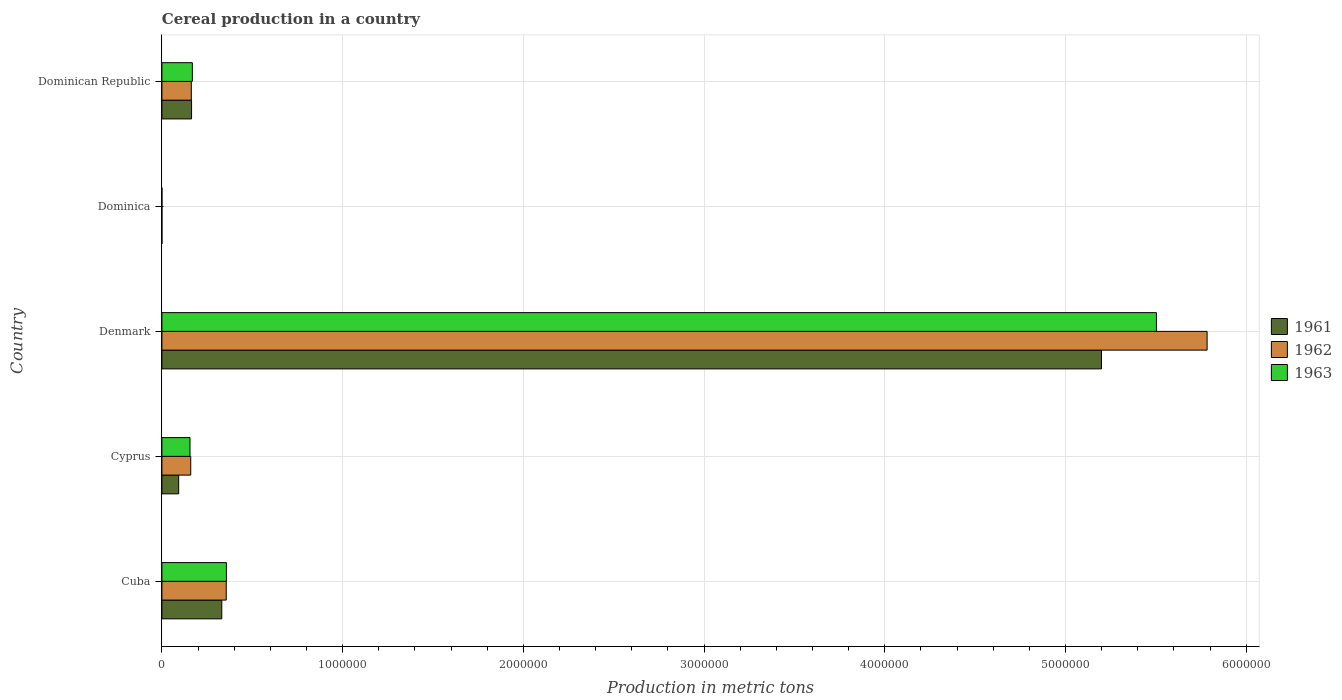How many bars are there on the 5th tick from the top?
Provide a succinct answer. 3. How many bars are there on the 4th tick from the bottom?
Ensure brevity in your answer.  3. What is the label of the 4th group of bars from the top?
Ensure brevity in your answer.  Cyprus. What is the total cereal production in 1961 in Dominican Republic?
Provide a short and direct response. 1.64e+05. Across all countries, what is the maximum total cereal production in 1963?
Provide a succinct answer. 5.50e+06. Across all countries, what is the minimum total cereal production in 1962?
Your answer should be compact. 130. In which country was the total cereal production in 1961 maximum?
Offer a terse response. Denmark. In which country was the total cereal production in 1961 minimum?
Your response must be concise. Dominica. What is the total total cereal production in 1962 in the graph?
Offer a very short reply. 6.46e+06. What is the difference between the total cereal production in 1963 in Cuba and that in Dominica?
Provide a succinct answer. 3.57e+05. What is the difference between the total cereal production in 1963 in Dominica and the total cereal production in 1962 in Cyprus?
Offer a terse response. -1.59e+05. What is the average total cereal production in 1963 per country?
Provide a short and direct response. 1.24e+06. What is the difference between the total cereal production in 1963 and total cereal production in 1962 in Denmark?
Ensure brevity in your answer.  -2.80e+05. What is the ratio of the total cereal production in 1962 in Cyprus to that in Dominica?
Provide a succinct answer. 1227.02. Is the total cereal production in 1961 in Cyprus less than that in Denmark?
Ensure brevity in your answer.  Yes. What is the difference between the highest and the second highest total cereal production in 1963?
Your answer should be very brief. 5.15e+06. What is the difference between the highest and the lowest total cereal production in 1962?
Make the answer very short. 5.78e+06. What does the 3rd bar from the top in Dominican Republic represents?
Your answer should be very brief. 1961. How many bars are there?
Make the answer very short. 15. Are all the bars in the graph horizontal?
Offer a terse response. Yes. What is the difference between two consecutive major ticks on the X-axis?
Your answer should be very brief. 1.00e+06. Where does the legend appear in the graph?
Provide a succinct answer. Center right. How many legend labels are there?
Provide a succinct answer. 3. How are the legend labels stacked?
Keep it short and to the point. Vertical. What is the title of the graph?
Keep it short and to the point. Cereal production in a country. What is the label or title of the X-axis?
Offer a very short reply. Production in metric tons. What is the Production in metric tons in 1961 in Cuba?
Your response must be concise. 3.31e+05. What is the Production in metric tons of 1962 in Cuba?
Offer a terse response. 3.56e+05. What is the Production in metric tons in 1963 in Cuba?
Keep it short and to the point. 3.57e+05. What is the Production in metric tons in 1961 in Cyprus?
Your answer should be compact. 9.28e+04. What is the Production in metric tons in 1962 in Cyprus?
Offer a terse response. 1.60e+05. What is the Production in metric tons in 1963 in Cyprus?
Give a very brief answer. 1.56e+05. What is the Production in metric tons of 1961 in Denmark?
Provide a succinct answer. 5.20e+06. What is the Production in metric tons in 1962 in Denmark?
Give a very brief answer. 5.78e+06. What is the Production in metric tons in 1963 in Denmark?
Keep it short and to the point. 5.50e+06. What is the Production in metric tons in 1961 in Dominica?
Make the answer very short. 130. What is the Production in metric tons in 1962 in Dominica?
Ensure brevity in your answer.  130. What is the Production in metric tons in 1963 in Dominica?
Give a very brief answer. 140. What is the Production in metric tons in 1961 in Dominican Republic?
Your answer should be very brief. 1.64e+05. What is the Production in metric tons of 1962 in Dominican Republic?
Provide a succinct answer. 1.63e+05. What is the Production in metric tons in 1963 in Dominican Republic?
Provide a succinct answer. 1.68e+05. Across all countries, what is the maximum Production in metric tons in 1961?
Give a very brief answer. 5.20e+06. Across all countries, what is the maximum Production in metric tons of 1962?
Your answer should be very brief. 5.78e+06. Across all countries, what is the maximum Production in metric tons of 1963?
Offer a very short reply. 5.50e+06. Across all countries, what is the minimum Production in metric tons in 1961?
Provide a short and direct response. 130. Across all countries, what is the minimum Production in metric tons in 1962?
Your answer should be very brief. 130. Across all countries, what is the minimum Production in metric tons in 1963?
Your response must be concise. 140. What is the total Production in metric tons of 1961 in the graph?
Provide a short and direct response. 5.79e+06. What is the total Production in metric tons of 1962 in the graph?
Your answer should be very brief. 6.46e+06. What is the total Production in metric tons in 1963 in the graph?
Ensure brevity in your answer.  6.18e+06. What is the difference between the Production in metric tons of 1961 in Cuba and that in Cyprus?
Your response must be concise. 2.39e+05. What is the difference between the Production in metric tons of 1962 in Cuba and that in Cyprus?
Your response must be concise. 1.97e+05. What is the difference between the Production in metric tons in 1963 in Cuba and that in Cyprus?
Provide a succinct answer. 2.01e+05. What is the difference between the Production in metric tons of 1961 in Cuba and that in Denmark?
Provide a succinct answer. -4.87e+06. What is the difference between the Production in metric tons in 1962 in Cuba and that in Denmark?
Ensure brevity in your answer.  -5.43e+06. What is the difference between the Production in metric tons in 1963 in Cuba and that in Denmark?
Your answer should be very brief. -5.15e+06. What is the difference between the Production in metric tons in 1961 in Cuba and that in Dominica?
Keep it short and to the point. 3.31e+05. What is the difference between the Production in metric tons of 1962 in Cuba and that in Dominica?
Offer a very short reply. 3.56e+05. What is the difference between the Production in metric tons in 1963 in Cuba and that in Dominica?
Offer a very short reply. 3.57e+05. What is the difference between the Production in metric tons in 1961 in Cuba and that in Dominican Republic?
Offer a very short reply. 1.67e+05. What is the difference between the Production in metric tons in 1962 in Cuba and that in Dominican Republic?
Your response must be concise. 1.93e+05. What is the difference between the Production in metric tons of 1963 in Cuba and that in Dominican Republic?
Make the answer very short. 1.88e+05. What is the difference between the Production in metric tons of 1961 in Cyprus and that in Denmark?
Give a very brief answer. -5.11e+06. What is the difference between the Production in metric tons in 1962 in Cyprus and that in Denmark?
Keep it short and to the point. -5.62e+06. What is the difference between the Production in metric tons in 1963 in Cyprus and that in Denmark?
Your response must be concise. -5.35e+06. What is the difference between the Production in metric tons of 1961 in Cyprus and that in Dominica?
Your answer should be very brief. 9.26e+04. What is the difference between the Production in metric tons of 1962 in Cyprus and that in Dominica?
Provide a succinct answer. 1.59e+05. What is the difference between the Production in metric tons of 1963 in Cyprus and that in Dominica?
Make the answer very short. 1.55e+05. What is the difference between the Production in metric tons of 1961 in Cyprus and that in Dominican Republic?
Provide a short and direct response. -7.13e+04. What is the difference between the Production in metric tons of 1962 in Cyprus and that in Dominican Republic?
Your answer should be very brief. -3252. What is the difference between the Production in metric tons in 1963 in Cyprus and that in Dominican Republic?
Your answer should be very brief. -1.29e+04. What is the difference between the Production in metric tons in 1961 in Denmark and that in Dominica?
Offer a terse response. 5.20e+06. What is the difference between the Production in metric tons in 1962 in Denmark and that in Dominica?
Offer a terse response. 5.78e+06. What is the difference between the Production in metric tons of 1963 in Denmark and that in Dominica?
Offer a terse response. 5.50e+06. What is the difference between the Production in metric tons of 1961 in Denmark and that in Dominican Republic?
Offer a terse response. 5.03e+06. What is the difference between the Production in metric tons in 1962 in Denmark and that in Dominican Republic?
Ensure brevity in your answer.  5.62e+06. What is the difference between the Production in metric tons in 1963 in Denmark and that in Dominican Republic?
Your answer should be very brief. 5.33e+06. What is the difference between the Production in metric tons in 1961 in Dominica and that in Dominican Republic?
Provide a succinct answer. -1.64e+05. What is the difference between the Production in metric tons in 1962 in Dominica and that in Dominican Republic?
Offer a terse response. -1.63e+05. What is the difference between the Production in metric tons in 1963 in Dominica and that in Dominican Republic?
Make the answer very short. -1.68e+05. What is the difference between the Production in metric tons of 1961 in Cuba and the Production in metric tons of 1962 in Cyprus?
Offer a very short reply. 1.72e+05. What is the difference between the Production in metric tons in 1961 in Cuba and the Production in metric tons in 1963 in Cyprus?
Offer a terse response. 1.76e+05. What is the difference between the Production in metric tons of 1962 in Cuba and the Production in metric tons of 1963 in Cyprus?
Keep it short and to the point. 2.00e+05. What is the difference between the Production in metric tons in 1961 in Cuba and the Production in metric tons in 1962 in Denmark?
Ensure brevity in your answer.  -5.45e+06. What is the difference between the Production in metric tons in 1961 in Cuba and the Production in metric tons in 1963 in Denmark?
Ensure brevity in your answer.  -5.17e+06. What is the difference between the Production in metric tons in 1962 in Cuba and the Production in metric tons in 1963 in Denmark?
Make the answer very short. -5.15e+06. What is the difference between the Production in metric tons in 1961 in Cuba and the Production in metric tons in 1962 in Dominica?
Offer a very short reply. 3.31e+05. What is the difference between the Production in metric tons of 1961 in Cuba and the Production in metric tons of 1963 in Dominica?
Give a very brief answer. 3.31e+05. What is the difference between the Production in metric tons in 1962 in Cuba and the Production in metric tons in 1963 in Dominica?
Give a very brief answer. 3.56e+05. What is the difference between the Production in metric tons of 1961 in Cuba and the Production in metric tons of 1962 in Dominican Republic?
Your answer should be very brief. 1.69e+05. What is the difference between the Production in metric tons in 1961 in Cuba and the Production in metric tons in 1963 in Dominican Republic?
Provide a short and direct response. 1.63e+05. What is the difference between the Production in metric tons in 1962 in Cuba and the Production in metric tons in 1963 in Dominican Republic?
Your response must be concise. 1.88e+05. What is the difference between the Production in metric tons in 1961 in Cyprus and the Production in metric tons in 1962 in Denmark?
Ensure brevity in your answer.  -5.69e+06. What is the difference between the Production in metric tons in 1961 in Cyprus and the Production in metric tons in 1963 in Denmark?
Provide a succinct answer. -5.41e+06. What is the difference between the Production in metric tons in 1962 in Cyprus and the Production in metric tons in 1963 in Denmark?
Provide a succinct answer. -5.34e+06. What is the difference between the Production in metric tons of 1961 in Cyprus and the Production in metric tons of 1962 in Dominica?
Your answer should be very brief. 9.26e+04. What is the difference between the Production in metric tons of 1961 in Cyprus and the Production in metric tons of 1963 in Dominica?
Make the answer very short. 9.26e+04. What is the difference between the Production in metric tons in 1962 in Cyprus and the Production in metric tons in 1963 in Dominica?
Ensure brevity in your answer.  1.59e+05. What is the difference between the Production in metric tons of 1961 in Cyprus and the Production in metric tons of 1962 in Dominican Republic?
Make the answer very short. -7.00e+04. What is the difference between the Production in metric tons of 1961 in Cyprus and the Production in metric tons of 1963 in Dominican Republic?
Provide a succinct answer. -7.57e+04. What is the difference between the Production in metric tons of 1962 in Cyprus and the Production in metric tons of 1963 in Dominican Republic?
Your answer should be very brief. -8920. What is the difference between the Production in metric tons in 1961 in Denmark and the Production in metric tons in 1962 in Dominica?
Your answer should be compact. 5.20e+06. What is the difference between the Production in metric tons of 1961 in Denmark and the Production in metric tons of 1963 in Dominica?
Ensure brevity in your answer.  5.20e+06. What is the difference between the Production in metric tons of 1962 in Denmark and the Production in metric tons of 1963 in Dominica?
Provide a short and direct response. 5.78e+06. What is the difference between the Production in metric tons of 1961 in Denmark and the Production in metric tons of 1962 in Dominican Republic?
Provide a succinct answer. 5.04e+06. What is the difference between the Production in metric tons in 1961 in Denmark and the Production in metric tons in 1963 in Dominican Republic?
Your answer should be very brief. 5.03e+06. What is the difference between the Production in metric tons in 1962 in Denmark and the Production in metric tons in 1963 in Dominican Republic?
Your answer should be very brief. 5.61e+06. What is the difference between the Production in metric tons in 1961 in Dominica and the Production in metric tons in 1962 in Dominican Republic?
Ensure brevity in your answer.  -1.63e+05. What is the difference between the Production in metric tons of 1961 in Dominica and the Production in metric tons of 1963 in Dominican Republic?
Give a very brief answer. -1.68e+05. What is the difference between the Production in metric tons of 1962 in Dominica and the Production in metric tons of 1963 in Dominican Republic?
Your answer should be very brief. -1.68e+05. What is the average Production in metric tons in 1961 per country?
Your response must be concise. 1.16e+06. What is the average Production in metric tons of 1962 per country?
Give a very brief answer. 1.29e+06. What is the average Production in metric tons of 1963 per country?
Your answer should be very brief. 1.24e+06. What is the difference between the Production in metric tons of 1961 and Production in metric tons of 1962 in Cuba?
Keep it short and to the point. -2.47e+04. What is the difference between the Production in metric tons in 1961 and Production in metric tons in 1963 in Cuba?
Provide a short and direct response. -2.56e+04. What is the difference between the Production in metric tons of 1962 and Production in metric tons of 1963 in Cuba?
Keep it short and to the point. -880. What is the difference between the Production in metric tons in 1961 and Production in metric tons in 1962 in Cyprus?
Provide a succinct answer. -6.68e+04. What is the difference between the Production in metric tons of 1961 and Production in metric tons of 1963 in Cyprus?
Offer a terse response. -6.28e+04. What is the difference between the Production in metric tons of 1962 and Production in metric tons of 1963 in Cyprus?
Make the answer very short. 3950. What is the difference between the Production in metric tons in 1961 and Production in metric tons in 1962 in Denmark?
Your answer should be compact. -5.85e+05. What is the difference between the Production in metric tons in 1961 and Production in metric tons in 1963 in Denmark?
Give a very brief answer. -3.04e+05. What is the difference between the Production in metric tons of 1962 and Production in metric tons of 1963 in Denmark?
Provide a succinct answer. 2.80e+05. What is the difference between the Production in metric tons of 1962 and Production in metric tons of 1963 in Dominica?
Your answer should be very brief. -10. What is the difference between the Production in metric tons of 1961 and Production in metric tons of 1962 in Dominican Republic?
Provide a short and direct response. 1325. What is the difference between the Production in metric tons in 1961 and Production in metric tons in 1963 in Dominican Republic?
Your answer should be very brief. -4343. What is the difference between the Production in metric tons in 1962 and Production in metric tons in 1963 in Dominican Republic?
Give a very brief answer. -5668. What is the ratio of the Production in metric tons of 1961 in Cuba to that in Cyprus?
Offer a very short reply. 3.57. What is the ratio of the Production in metric tons in 1962 in Cuba to that in Cyprus?
Give a very brief answer. 2.23. What is the ratio of the Production in metric tons in 1963 in Cuba to that in Cyprus?
Your answer should be compact. 2.29. What is the ratio of the Production in metric tons of 1961 in Cuba to that in Denmark?
Provide a succinct answer. 0.06. What is the ratio of the Production in metric tons of 1962 in Cuba to that in Denmark?
Provide a succinct answer. 0.06. What is the ratio of the Production in metric tons in 1963 in Cuba to that in Denmark?
Provide a short and direct response. 0.06. What is the ratio of the Production in metric tons of 1961 in Cuba to that in Dominica?
Give a very brief answer. 2548.52. What is the ratio of the Production in metric tons in 1962 in Cuba to that in Dominica?
Give a very brief answer. 2738.62. What is the ratio of the Production in metric tons in 1963 in Cuba to that in Dominica?
Offer a terse response. 2549.29. What is the ratio of the Production in metric tons of 1961 in Cuba to that in Dominican Republic?
Your answer should be compact. 2.02. What is the ratio of the Production in metric tons in 1962 in Cuba to that in Dominican Republic?
Ensure brevity in your answer.  2.19. What is the ratio of the Production in metric tons in 1963 in Cuba to that in Dominican Republic?
Offer a terse response. 2.12. What is the ratio of the Production in metric tons in 1961 in Cyprus to that in Denmark?
Keep it short and to the point. 0.02. What is the ratio of the Production in metric tons of 1962 in Cyprus to that in Denmark?
Keep it short and to the point. 0.03. What is the ratio of the Production in metric tons in 1963 in Cyprus to that in Denmark?
Offer a very short reply. 0.03. What is the ratio of the Production in metric tons in 1961 in Cyprus to that in Dominica?
Give a very brief answer. 713.55. What is the ratio of the Production in metric tons in 1962 in Cyprus to that in Dominica?
Your answer should be compact. 1227.02. What is the ratio of the Production in metric tons of 1963 in Cyprus to that in Dominica?
Provide a succinct answer. 1111.16. What is the ratio of the Production in metric tons of 1961 in Cyprus to that in Dominican Republic?
Make the answer very short. 0.57. What is the ratio of the Production in metric tons in 1963 in Cyprus to that in Dominican Republic?
Give a very brief answer. 0.92. What is the ratio of the Production in metric tons of 1961 in Denmark to that in Dominica?
Make the answer very short. 4.00e+04. What is the ratio of the Production in metric tons in 1962 in Denmark to that in Dominica?
Provide a short and direct response. 4.45e+04. What is the ratio of the Production in metric tons of 1963 in Denmark to that in Dominica?
Your answer should be very brief. 3.93e+04. What is the ratio of the Production in metric tons of 1961 in Denmark to that in Dominican Republic?
Ensure brevity in your answer.  31.68. What is the ratio of the Production in metric tons in 1962 in Denmark to that in Dominican Republic?
Offer a terse response. 35.53. What is the ratio of the Production in metric tons of 1963 in Denmark to that in Dominican Republic?
Your response must be concise. 32.67. What is the ratio of the Production in metric tons in 1961 in Dominica to that in Dominican Republic?
Give a very brief answer. 0. What is the ratio of the Production in metric tons of 1962 in Dominica to that in Dominican Republic?
Your answer should be compact. 0. What is the ratio of the Production in metric tons in 1963 in Dominica to that in Dominican Republic?
Offer a very short reply. 0. What is the difference between the highest and the second highest Production in metric tons in 1961?
Your answer should be compact. 4.87e+06. What is the difference between the highest and the second highest Production in metric tons of 1962?
Your answer should be compact. 5.43e+06. What is the difference between the highest and the second highest Production in metric tons in 1963?
Ensure brevity in your answer.  5.15e+06. What is the difference between the highest and the lowest Production in metric tons in 1961?
Provide a short and direct response. 5.20e+06. What is the difference between the highest and the lowest Production in metric tons of 1962?
Offer a very short reply. 5.78e+06. What is the difference between the highest and the lowest Production in metric tons of 1963?
Your answer should be very brief. 5.50e+06. 